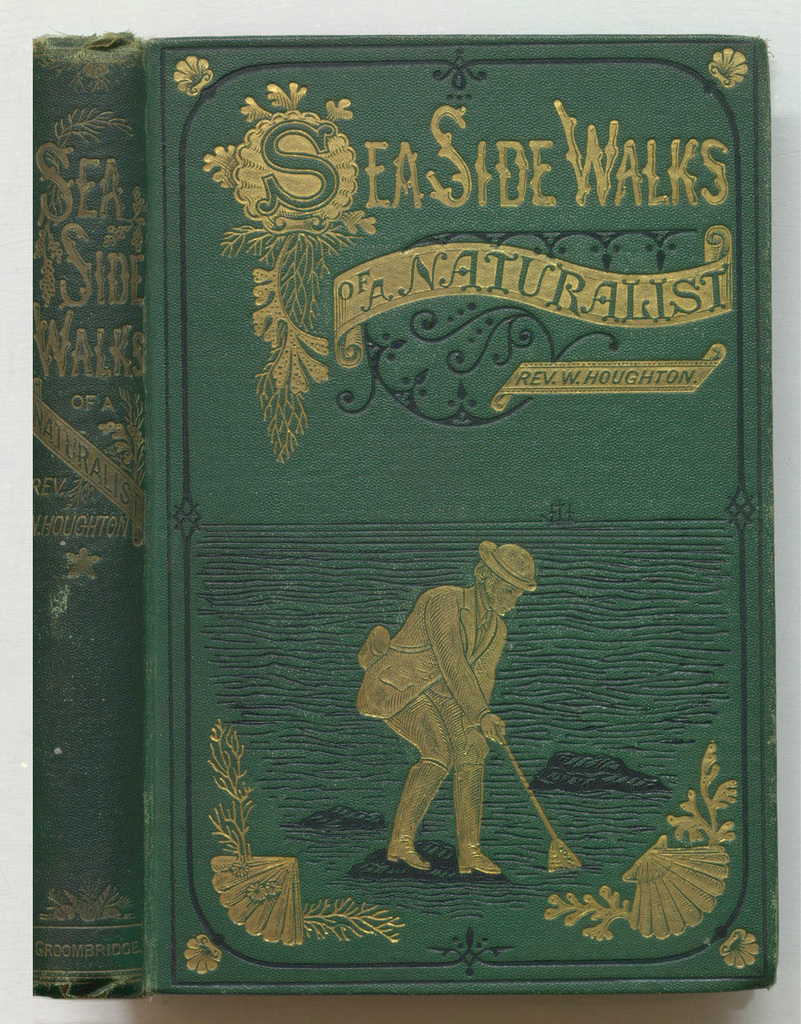Provide a one-sentence caption for the provided image. The image depicts an intricately designed book cover of 'SeaSide Walks of a Naturalist' by Rev. W. Houghton, featuring gold embossing of a naturalist exploring the seaside, rendered in rich detail against a dark green backdrop. 